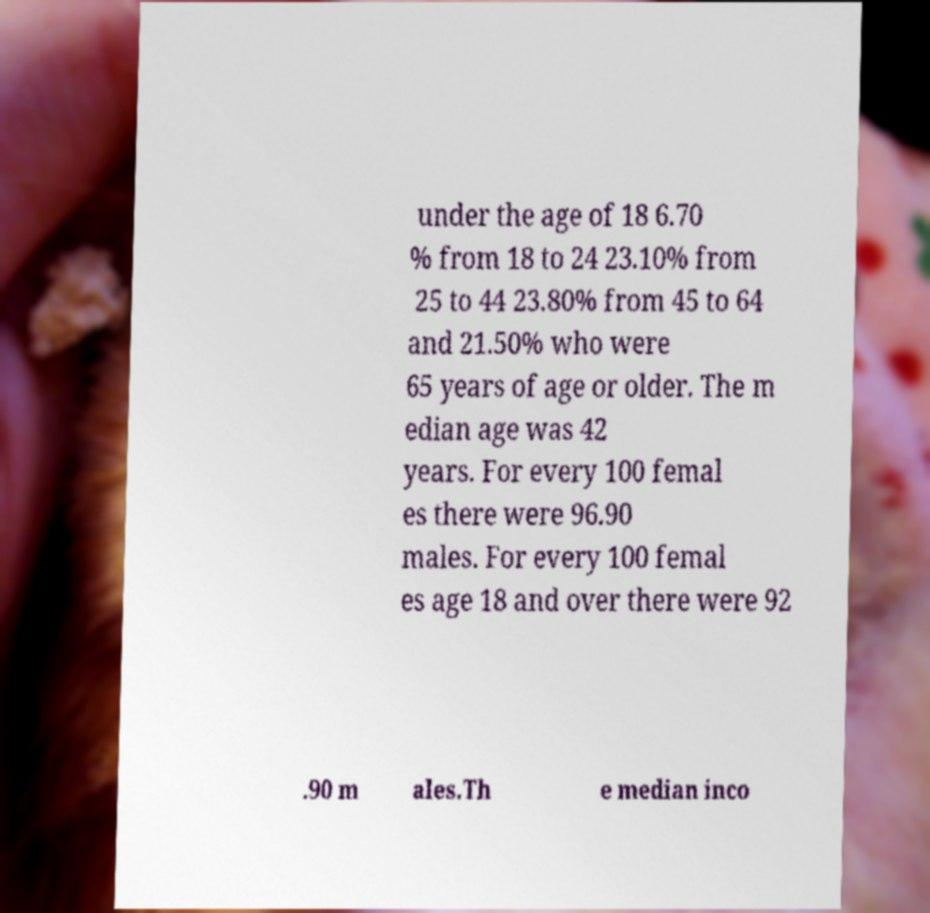For documentation purposes, I need the text within this image transcribed. Could you provide that? under the age of 18 6.70 % from 18 to 24 23.10% from 25 to 44 23.80% from 45 to 64 and 21.50% who were 65 years of age or older. The m edian age was 42 years. For every 100 femal es there were 96.90 males. For every 100 femal es age 18 and over there were 92 .90 m ales.Th e median inco 